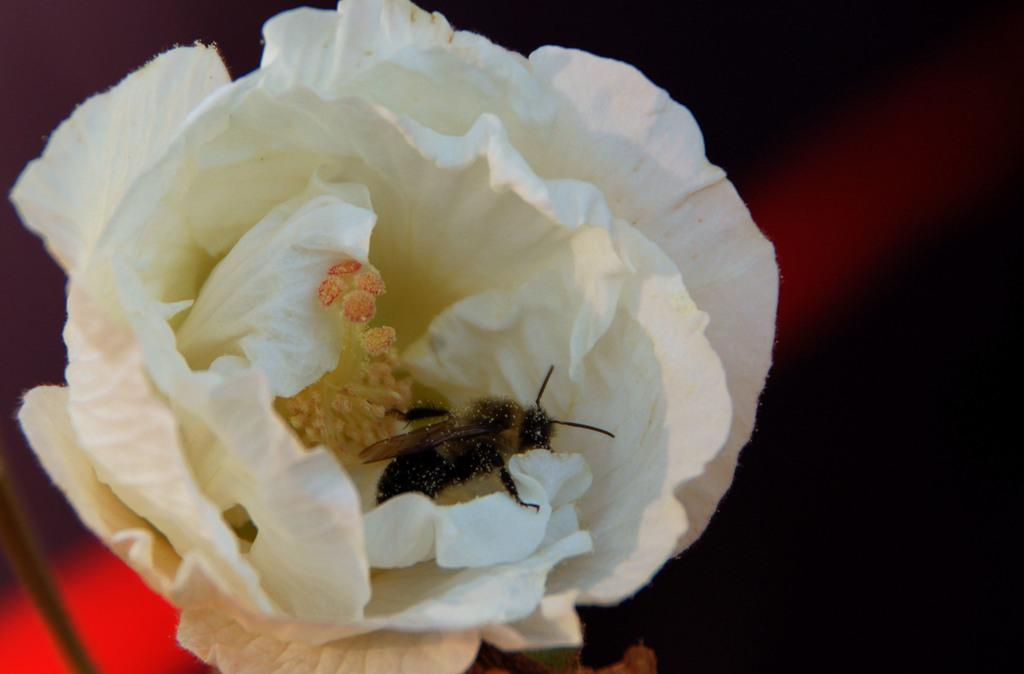What is the main subject of the image? There is a white color flower in the center of the image. Is there anything else present in the flower? A fly appears to be in the flower. What can be seen in the background of the image? There are other items visible in the background of the image. What type of act is the hospital performing in the image? There is no hospital or act present in the image; it features a white color flower with a fly in it. 